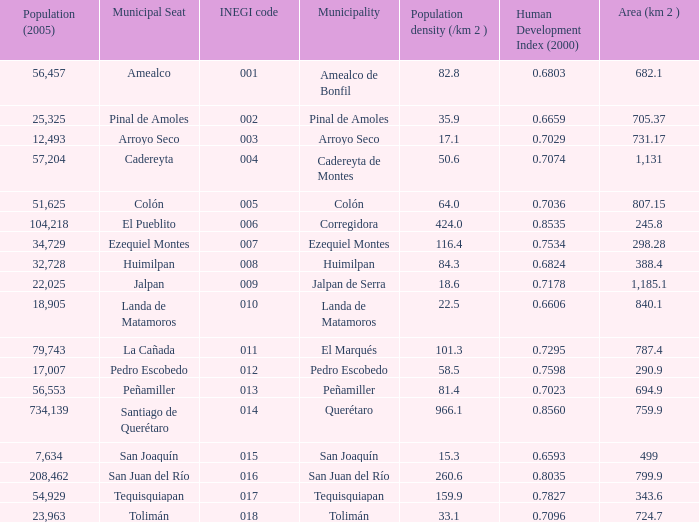WHat is the amount of Human Development Index (2000) that has a Population (2005) of 54,929, and an Area (km 2 ) larger than 343.6? 0.0. 